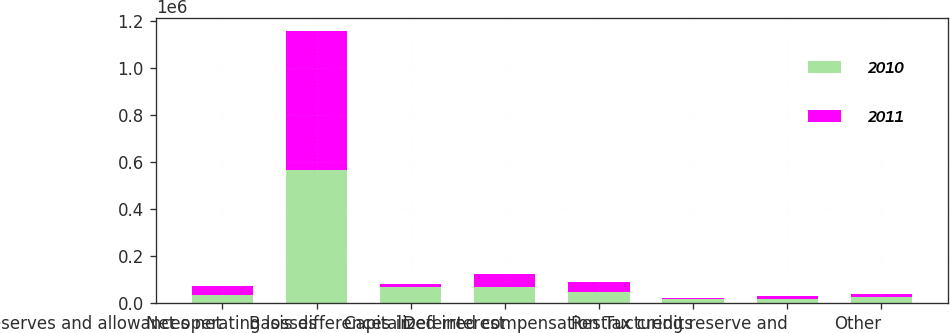Convert chart. <chart><loc_0><loc_0><loc_500><loc_500><stacked_bar_chart><ecel><fcel>Reserves and allowances net<fcel>Net operating losses<fcel>Basis differences in<fcel>Capitalized interest<fcel>Deferred compensation<fcel>Tax credits<fcel>Restructuring reserve and<fcel>Other<nl><fcel>2010<fcel>35810.5<fcel>567774<fcel>67738<fcel>65767<fcel>44512<fcel>16169<fcel>15092<fcel>27109<nl><fcel>2011<fcel>35810.5<fcel>588178<fcel>13830<fcel>59075<fcel>45472<fcel>6383<fcel>15523<fcel>12762<nl></chart> 